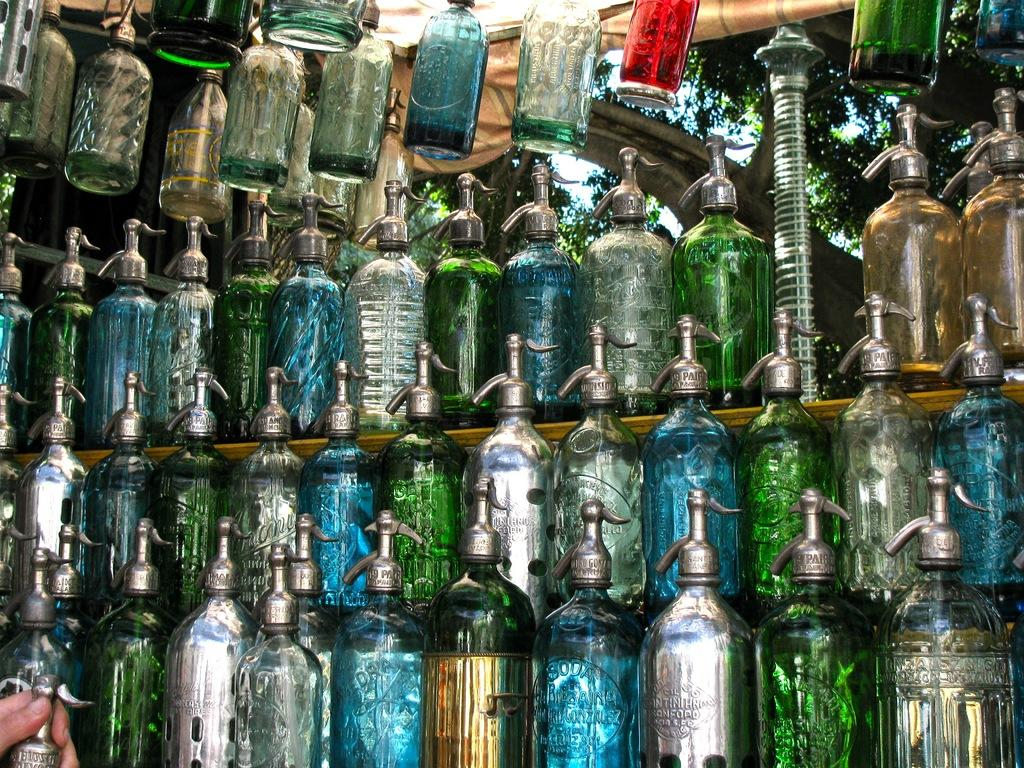What objects can be seen in the image? There are bottles in the image. Can you describe any other elements in the image? Yes, there is a hand of a person visible in the image. What type of gate can be seen in the image? There is no gate present in the image; it only features bottles and a hand. How many snails are crawling on the bottles in the image? There are no snails visible in the image. 